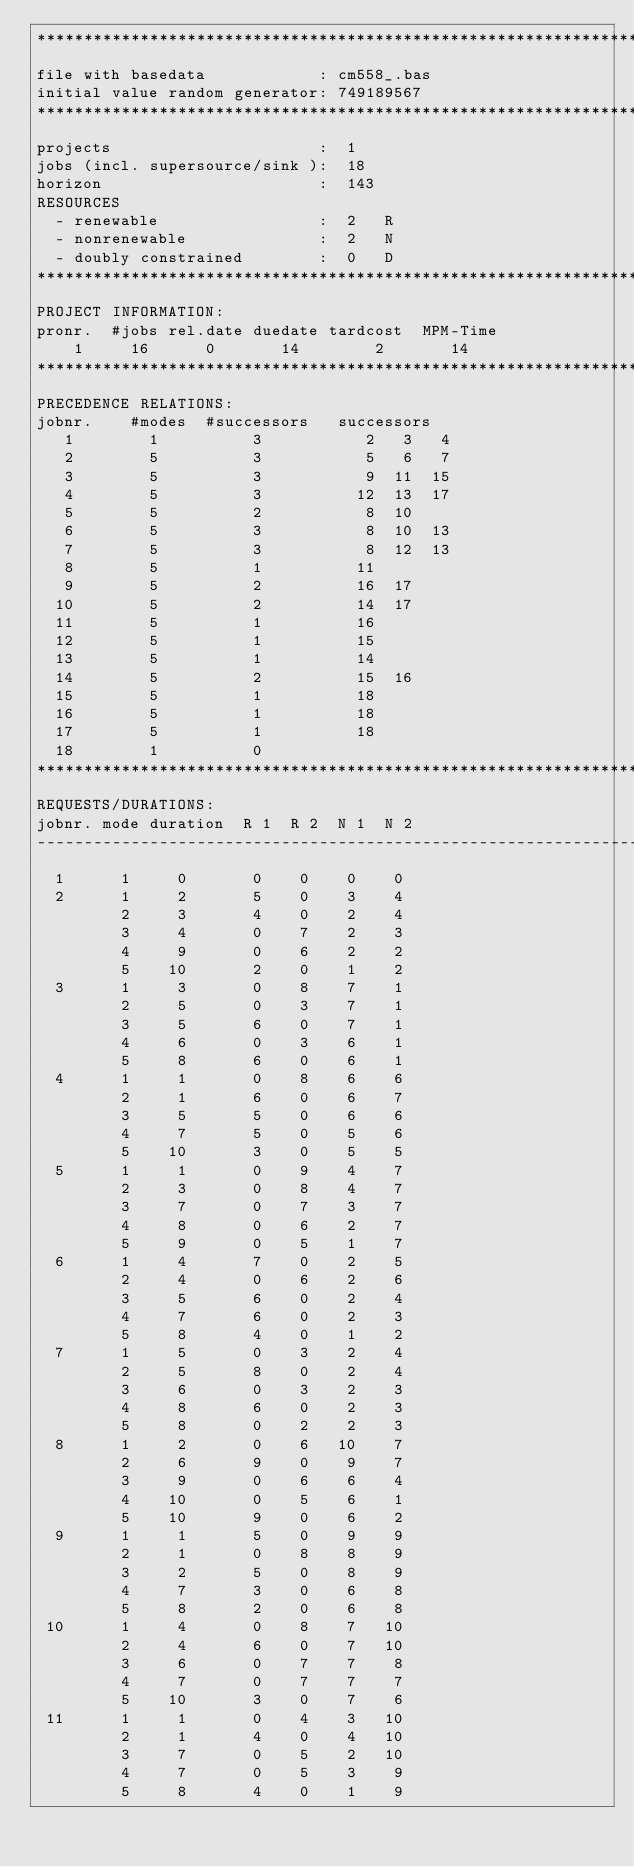<code> <loc_0><loc_0><loc_500><loc_500><_ObjectiveC_>************************************************************************
file with basedata            : cm558_.bas
initial value random generator: 749189567
************************************************************************
projects                      :  1
jobs (incl. supersource/sink ):  18
horizon                       :  143
RESOURCES
  - renewable                 :  2   R
  - nonrenewable              :  2   N
  - doubly constrained        :  0   D
************************************************************************
PROJECT INFORMATION:
pronr.  #jobs rel.date duedate tardcost  MPM-Time
    1     16      0       14        2       14
************************************************************************
PRECEDENCE RELATIONS:
jobnr.    #modes  #successors   successors
   1        1          3           2   3   4
   2        5          3           5   6   7
   3        5          3           9  11  15
   4        5          3          12  13  17
   5        5          2           8  10
   6        5          3           8  10  13
   7        5          3           8  12  13
   8        5          1          11
   9        5          2          16  17
  10        5          2          14  17
  11        5          1          16
  12        5          1          15
  13        5          1          14
  14        5          2          15  16
  15        5          1          18
  16        5          1          18
  17        5          1          18
  18        1          0        
************************************************************************
REQUESTS/DURATIONS:
jobnr. mode duration  R 1  R 2  N 1  N 2
------------------------------------------------------------------------
  1      1     0       0    0    0    0
  2      1     2       5    0    3    4
         2     3       4    0    2    4
         3     4       0    7    2    3
         4     9       0    6    2    2
         5    10       2    0    1    2
  3      1     3       0    8    7    1
         2     5       0    3    7    1
         3     5       6    0    7    1
         4     6       0    3    6    1
         5     8       6    0    6    1
  4      1     1       0    8    6    6
         2     1       6    0    6    7
         3     5       5    0    6    6
         4     7       5    0    5    6
         5    10       3    0    5    5
  5      1     1       0    9    4    7
         2     3       0    8    4    7
         3     7       0    7    3    7
         4     8       0    6    2    7
         5     9       0    5    1    7
  6      1     4       7    0    2    5
         2     4       0    6    2    6
         3     5       6    0    2    4
         4     7       6    0    2    3
         5     8       4    0    1    2
  7      1     5       0    3    2    4
         2     5       8    0    2    4
         3     6       0    3    2    3
         4     8       6    0    2    3
         5     8       0    2    2    3
  8      1     2       0    6   10    7
         2     6       9    0    9    7
         3     9       0    6    6    4
         4    10       0    5    6    1
         5    10       9    0    6    2
  9      1     1       5    0    9    9
         2     1       0    8    8    9
         3     2       5    0    8    9
         4     7       3    0    6    8
         5     8       2    0    6    8
 10      1     4       0    8    7   10
         2     4       6    0    7   10
         3     6       0    7    7    8
         4     7       0    7    7    7
         5    10       3    0    7    6
 11      1     1       0    4    3   10
         2     1       4    0    4   10
         3     7       0    5    2   10
         4     7       0    5    3    9
         5     8       4    0    1    9</code> 